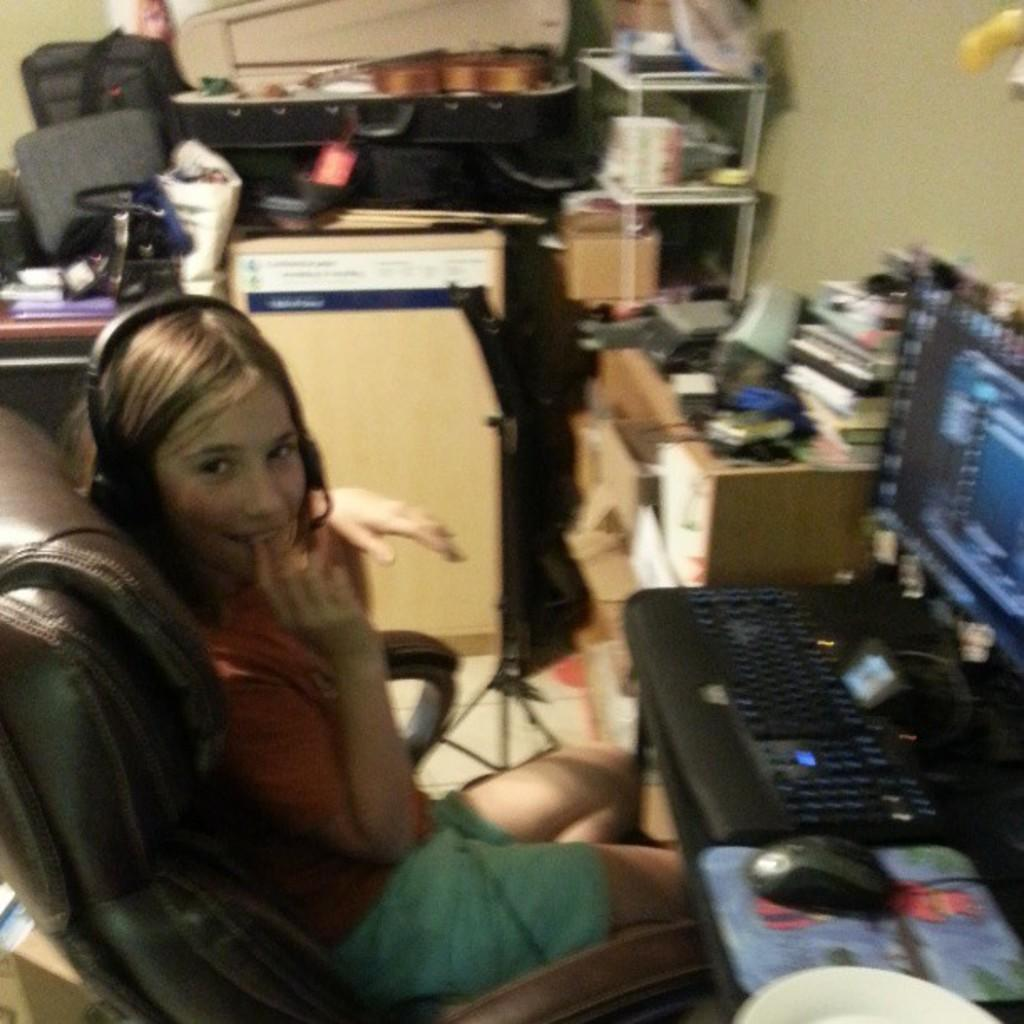What is the main subject of the image? There is a person in the image. What is the person wearing? The person is wearing a pink shirt. What is the person doing in the image? The person is sitting in a chair. What is the person wearing on their head? The person is wearing a headset. What is in front of the person? There is a computer in front of the person. What other items can be seen beside the person? There are other unspecified items beside the person. What type of current can be seen flowing through the person's body in the image? There is no current flowing through the person's body in the image. 